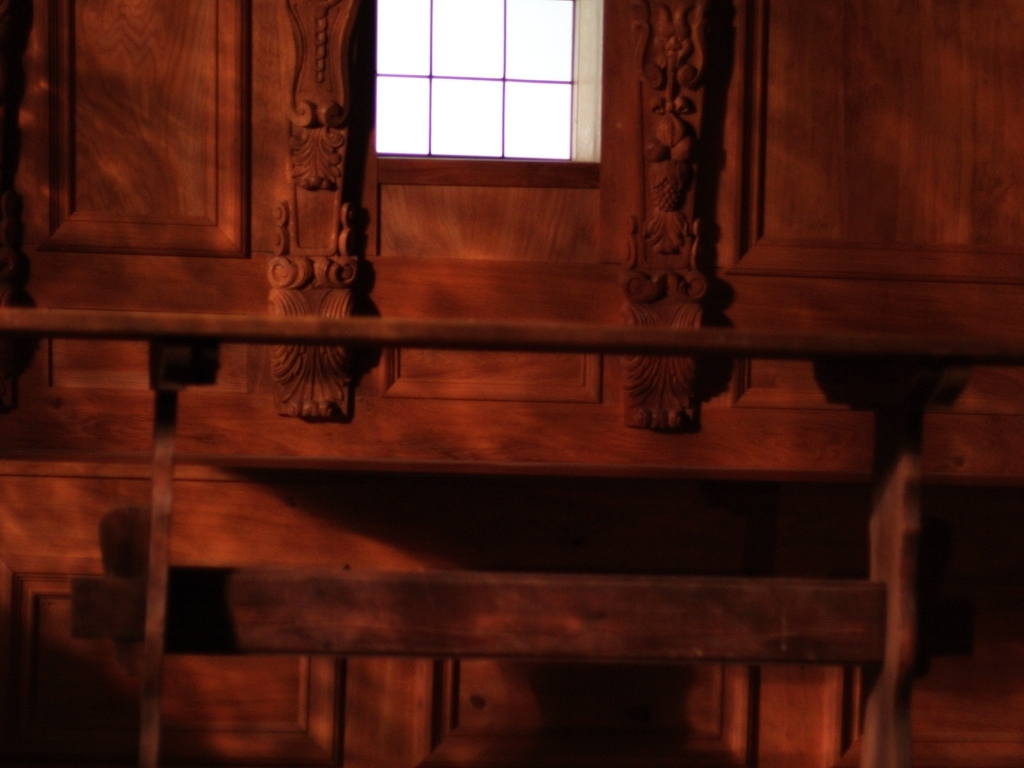Can you comment on the architectural style visible in the image? The ornately carved woodwork suggests a historical or traditional setting, reminiscent of certain European styles, such as the Baroque or Renaissance periods where craftsmanship was highly valued. 